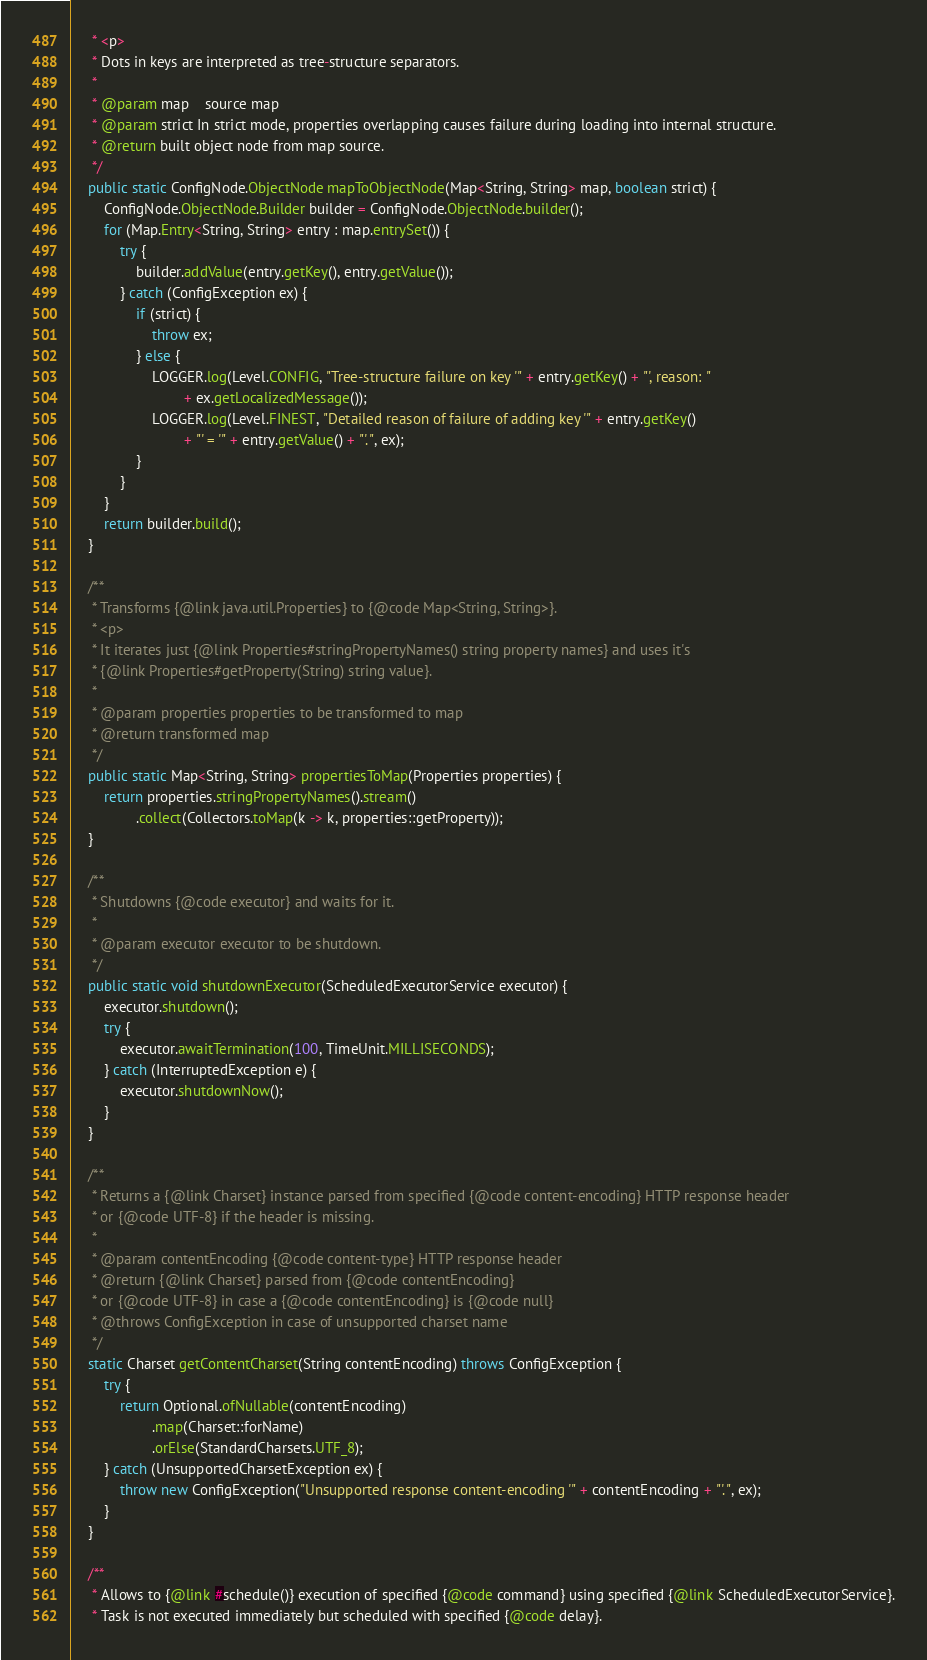Convert code to text. <code><loc_0><loc_0><loc_500><loc_500><_Java_>     * <p>
     * Dots in keys are interpreted as tree-structure separators.
     *
     * @param map    source map
     * @param strict In strict mode, properties overlapping causes failure during loading into internal structure.
     * @return built object node from map source.
     */
    public static ConfigNode.ObjectNode mapToObjectNode(Map<String, String> map, boolean strict) {
        ConfigNode.ObjectNode.Builder builder = ConfigNode.ObjectNode.builder();
        for (Map.Entry<String, String> entry : map.entrySet()) {
            try {
                builder.addValue(entry.getKey(), entry.getValue());
            } catch (ConfigException ex) {
                if (strict) {
                    throw ex;
                } else {
                    LOGGER.log(Level.CONFIG, "Tree-structure failure on key '" + entry.getKey() + "', reason: "
                            + ex.getLocalizedMessage());
                    LOGGER.log(Level.FINEST, "Detailed reason of failure of adding key '" + entry.getKey()
                            + "' = '" + entry.getValue() + "'.", ex);
                }
            }
        }
        return builder.build();
    }

    /**
     * Transforms {@link java.util.Properties} to {@code Map<String, String>}.
     * <p>
     * It iterates just {@link Properties#stringPropertyNames() string property names} and uses it's
     * {@link Properties#getProperty(String) string value}.
     *
     * @param properties properties to be transformed to map
     * @return transformed map
     */
    public static Map<String, String> propertiesToMap(Properties properties) {
        return properties.stringPropertyNames().stream()
                .collect(Collectors.toMap(k -> k, properties::getProperty));
    }

    /**
     * Shutdowns {@code executor} and waits for it.
     *
     * @param executor executor to be shutdown.
     */
    public static void shutdownExecutor(ScheduledExecutorService executor) {
        executor.shutdown();
        try {
            executor.awaitTermination(100, TimeUnit.MILLISECONDS);
        } catch (InterruptedException e) {
            executor.shutdownNow();
        }
    }

    /**
     * Returns a {@link Charset} instance parsed from specified {@code content-encoding} HTTP response header
     * or {@code UTF-8} if the header is missing.
     *
     * @param contentEncoding {@code content-type} HTTP response header
     * @return {@link Charset} parsed from {@code contentEncoding}
     * or {@code UTF-8} in case a {@code contentEncoding} is {@code null}
     * @throws ConfigException in case of unsupported charset name
     */
    static Charset getContentCharset(String contentEncoding) throws ConfigException {
        try {
            return Optional.ofNullable(contentEncoding)
                    .map(Charset::forName)
                    .orElse(StandardCharsets.UTF_8);
        } catch (UnsupportedCharsetException ex) {
            throw new ConfigException("Unsupported response content-encoding '" + contentEncoding + "'.", ex);
        }
    }

    /**
     * Allows to {@link #schedule()} execution of specified {@code command} using specified {@link ScheduledExecutorService}.
     * Task is not executed immediately but scheduled with specified {@code delay}.</code> 